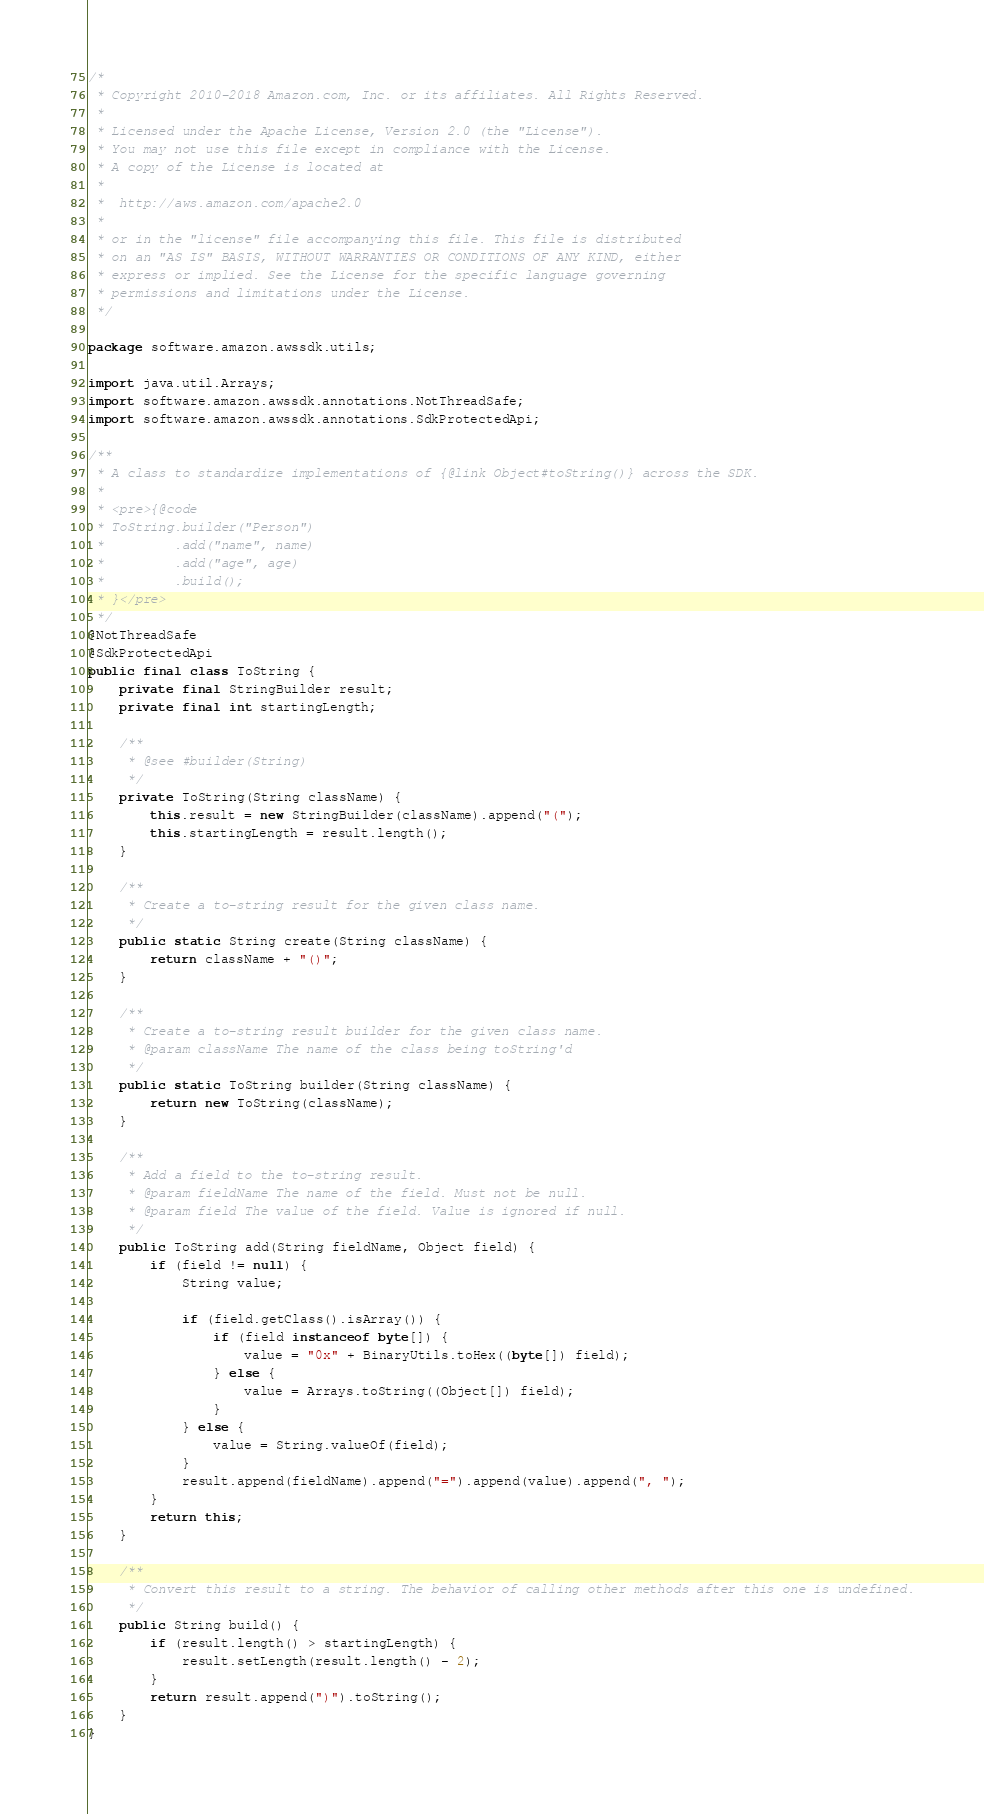<code> <loc_0><loc_0><loc_500><loc_500><_Java_>/*
 * Copyright 2010-2018 Amazon.com, Inc. or its affiliates. All Rights Reserved.
 *
 * Licensed under the Apache License, Version 2.0 (the "License").
 * You may not use this file except in compliance with the License.
 * A copy of the License is located at
 *
 *  http://aws.amazon.com/apache2.0
 *
 * or in the "license" file accompanying this file. This file is distributed
 * on an "AS IS" BASIS, WITHOUT WARRANTIES OR CONDITIONS OF ANY KIND, either
 * express or implied. See the License for the specific language governing
 * permissions and limitations under the License.
 */

package software.amazon.awssdk.utils;

import java.util.Arrays;
import software.amazon.awssdk.annotations.NotThreadSafe;
import software.amazon.awssdk.annotations.SdkProtectedApi;

/**
 * A class to standardize implementations of {@link Object#toString()} across the SDK.
 *
 * <pre>{@code
 * ToString.builder("Person")
 *         .add("name", name)
 *         .add("age", age)
 *         .build();
 * }</pre>
 */
@NotThreadSafe
@SdkProtectedApi
public final class ToString {
    private final StringBuilder result;
    private final int startingLength;

    /**
     * @see #builder(String)
     */
    private ToString(String className) {
        this.result = new StringBuilder(className).append("(");
        this.startingLength = result.length();
    }

    /**
     * Create a to-string result for the given class name.
     */
    public static String create(String className) {
        return className + "()";
    }

    /**
     * Create a to-string result builder for the given class name.
     * @param className The name of the class being toString'd
     */
    public static ToString builder(String className) {
        return new ToString(className);
    }

    /**
     * Add a field to the to-string result.
     * @param fieldName The name of the field. Must not be null.
     * @param field The value of the field. Value is ignored if null.
     */
    public ToString add(String fieldName, Object field) {
        if (field != null) {
            String value;

            if (field.getClass().isArray()) {
                if (field instanceof byte[]) {
                    value = "0x" + BinaryUtils.toHex((byte[]) field);
                } else {
                    value = Arrays.toString((Object[]) field);
                }
            } else {
                value = String.valueOf(field);
            }
            result.append(fieldName).append("=").append(value).append(", ");
        }
        return this;
    }

    /**
     * Convert this result to a string. The behavior of calling other methods after this one is undefined.
     */
    public String build() {
        if (result.length() > startingLength) {
            result.setLength(result.length() - 2);
        }
        return result.append(")").toString();
    }
}
</code> 